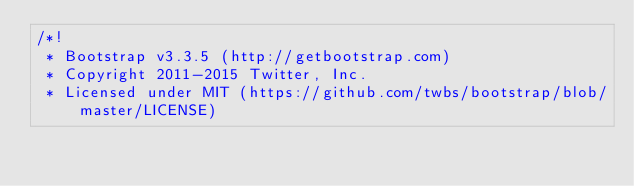<code> <loc_0><loc_0><loc_500><loc_500><_CSS_>/*!
 * Bootstrap v3.3.5 (http://getbootstrap.com)
 * Copyright 2011-2015 Twitter, Inc.
 * Licensed under MIT (https://github.com/twbs/bootstrap/blob/master/LICENSE)</code> 